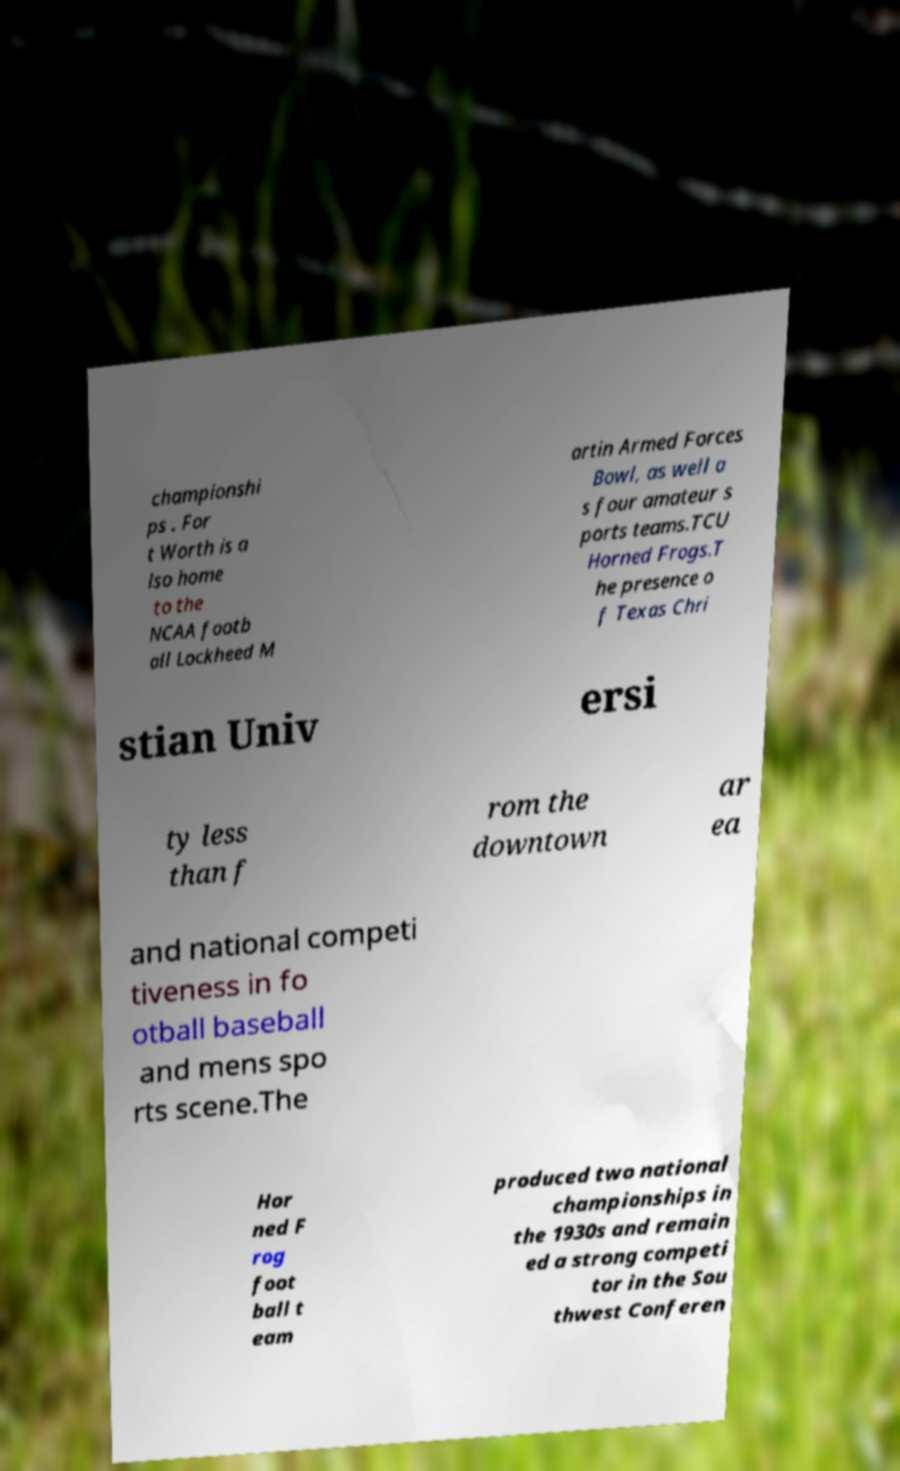There's text embedded in this image that I need extracted. Can you transcribe it verbatim? championshi ps . For t Worth is a lso home to the NCAA footb all Lockheed M artin Armed Forces Bowl, as well a s four amateur s ports teams.TCU Horned Frogs.T he presence o f Texas Chri stian Univ ersi ty less than f rom the downtown ar ea and national competi tiveness in fo otball baseball and mens spo rts scene.The Hor ned F rog foot ball t eam produced two national championships in the 1930s and remain ed a strong competi tor in the Sou thwest Conferen 